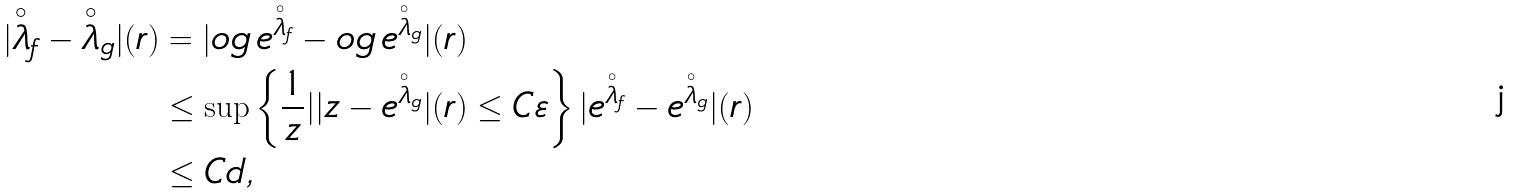Convert formula to latex. <formula><loc_0><loc_0><loc_500><loc_500>| \overset { \circ } { \lambda } _ { f } - \overset { \circ } { \lambda } _ { g } | ( r ) & = | \L o g \, e ^ { \overset { \circ } { \lambda } _ { f } } - \L o g \, e ^ { \overset { \circ } { \lambda } _ { g } } | ( r ) \\ & \leq \sup \left \{ \frac { 1 } { z } | | z - e ^ { \overset { \circ } { \lambda } _ { g } } | ( r ) \leq C \varepsilon \right \} | e ^ { \overset { \circ } { \lambda } _ { f } } - e ^ { \overset { \circ } { \lambda } _ { g } } | ( r ) \\ & \leq C d ,</formula> 